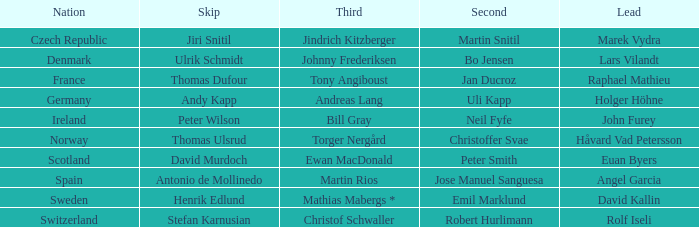Which third contains a nation of scotland? Ewan MacDonald. 